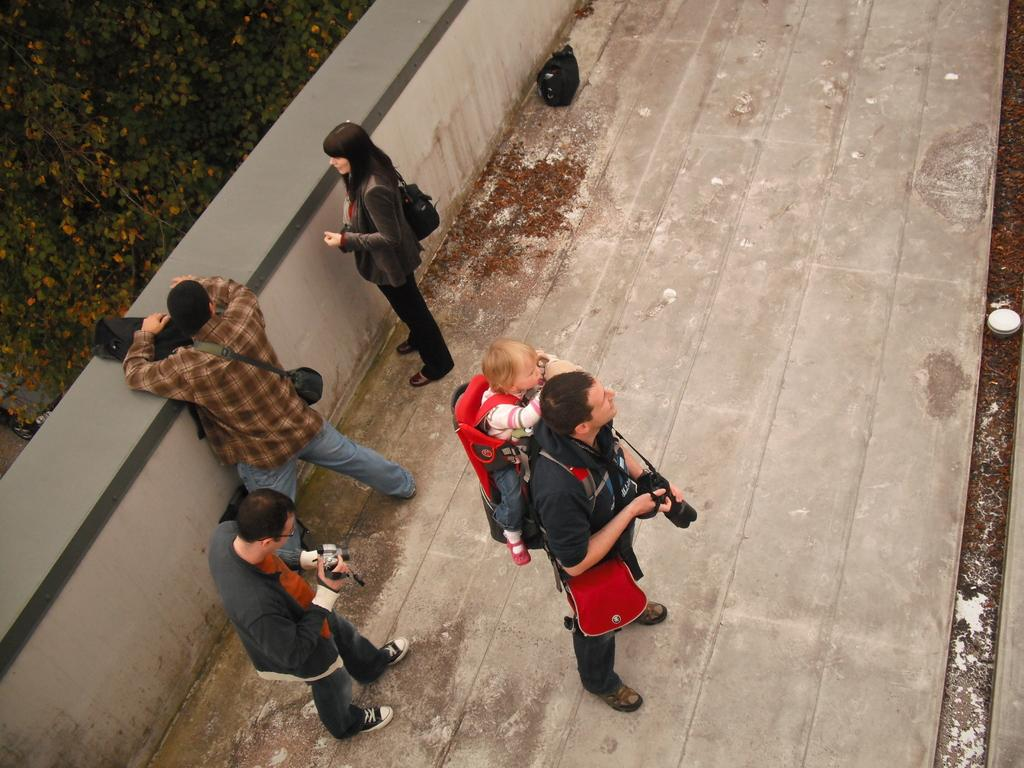What are the people in the image doing? The people in the image are standing on the floor. What objects are some people holding in the image? Some people are holding cameras in the image. What type of stone can be seen in the image? There is no stone present in the image. What noise can be heard coming from the people in the image? The image is a still picture, so no noise can be heard. 